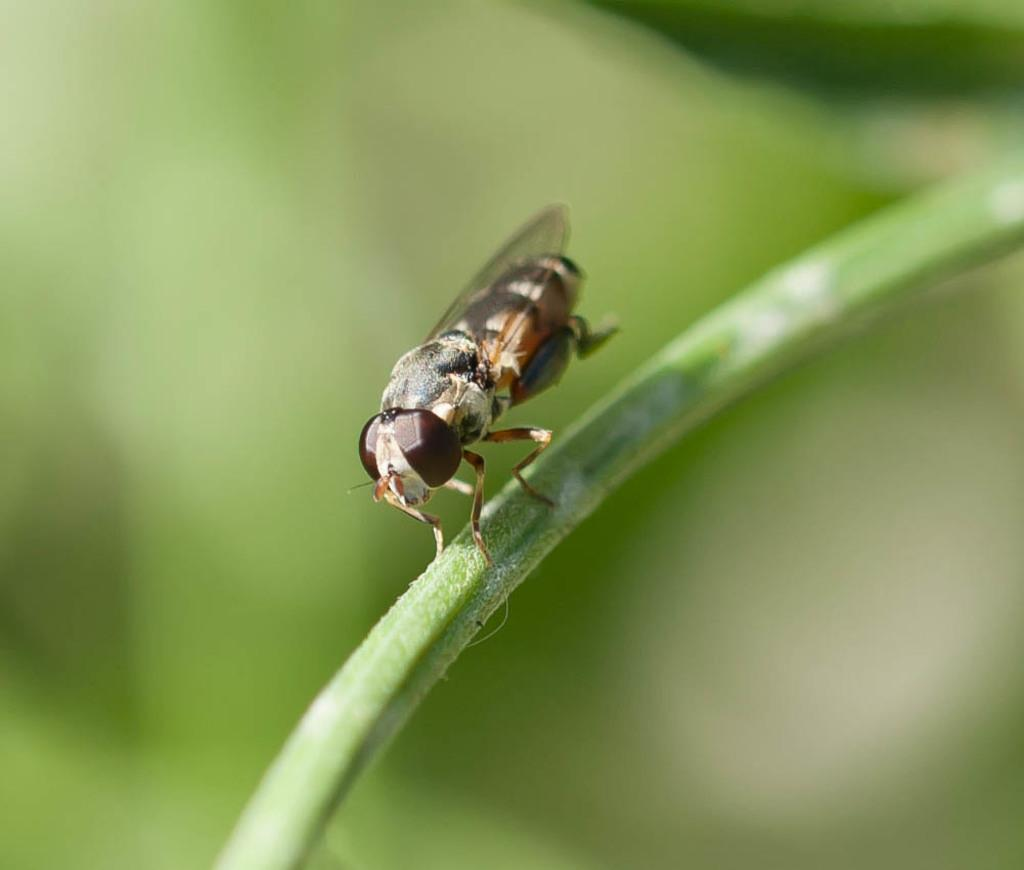What insect is present in the image? There is a house fly in the image. Where is the house fly located in the image? The house fly is standing on the stem of a plant. What type of steam can be seen coming from the hen in the image? There is no hen or steam present in the image; it features a house fly on the stem of a plant. 